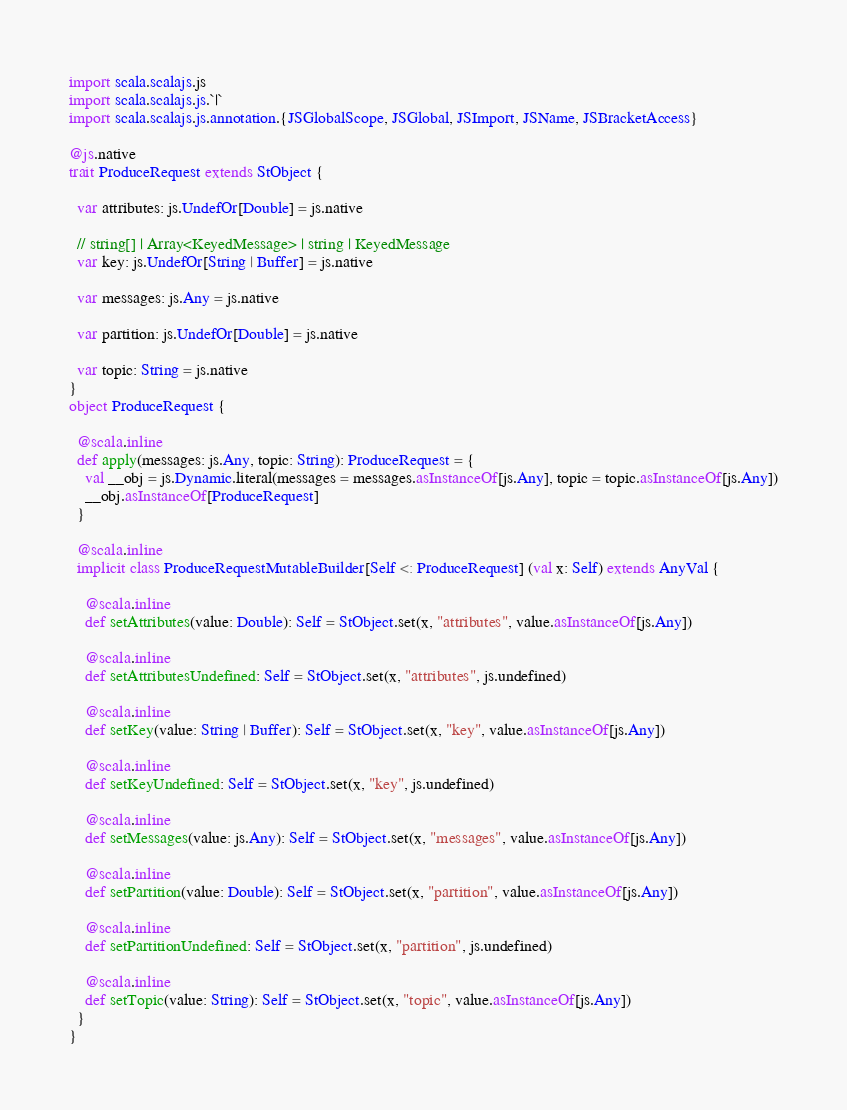<code> <loc_0><loc_0><loc_500><loc_500><_Scala_>import scala.scalajs.js
import scala.scalajs.js.`|`
import scala.scalajs.js.annotation.{JSGlobalScope, JSGlobal, JSImport, JSName, JSBracketAccess}

@js.native
trait ProduceRequest extends StObject {
  
  var attributes: js.UndefOr[Double] = js.native
  
  // string[] | Array<KeyedMessage> | string | KeyedMessage
  var key: js.UndefOr[String | Buffer] = js.native
  
  var messages: js.Any = js.native
  
  var partition: js.UndefOr[Double] = js.native
  
  var topic: String = js.native
}
object ProduceRequest {
  
  @scala.inline
  def apply(messages: js.Any, topic: String): ProduceRequest = {
    val __obj = js.Dynamic.literal(messages = messages.asInstanceOf[js.Any], topic = topic.asInstanceOf[js.Any])
    __obj.asInstanceOf[ProduceRequest]
  }
  
  @scala.inline
  implicit class ProduceRequestMutableBuilder[Self <: ProduceRequest] (val x: Self) extends AnyVal {
    
    @scala.inline
    def setAttributes(value: Double): Self = StObject.set(x, "attributes", value.asInstanceOf[js.Any])
    
    @scala.inline
    def setAttributesUndefined: Self = StObject.set(x, "attributes", js.undefined)
    
    @scala.inline
    def setKey(value: String | Buffer): Self = StObject.set(x, "key", value.asInstanceOf[js.Any])
    
    @scala.inline
    def setKeyUndefined: Self = StObject.set(x, "key", js.undefined)
    
    @scala.inline
    def setMessages(value: js.Any): Self = StObject.set(x, "messages", value.asInstanceOf[js.Any])
    
    @scala.inline
    def setPartition(value: Double): Self = StObject.set(x, "partition", value.asInstanceOf[js.Any])
    
    @scala.inline
    def setPartitionUndefined: Self = StObject.set(x, "partition", js.undefined)
    
    @scala.inline
    def setTopic(value: String): Self = StObject.set(x, "topic", value.asInstanceOf[js.Any])
  }
}
</code> 